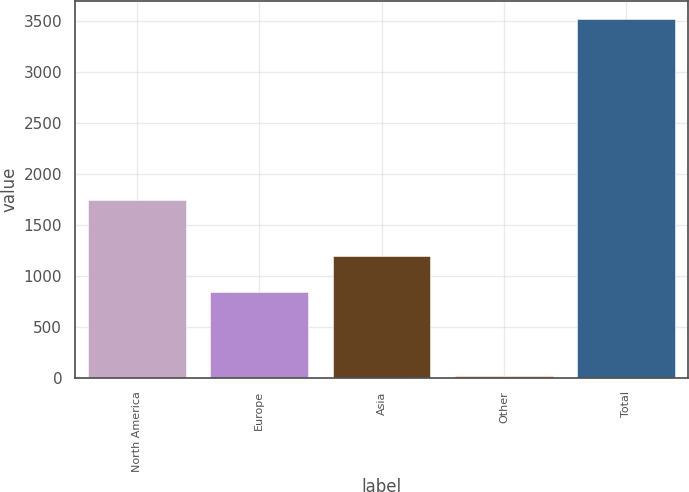<chart> <loc_0><loc_0><loc_500><loc_500><bar_chart><fcel>North America<fcel>Europe<fcel>Asia<fcel>Other<fcel>Total<nl><fcel>1745<fcel>848.1<fcel>1198.35<fcel>21.2<fcel>3523.7<nl></chart> 